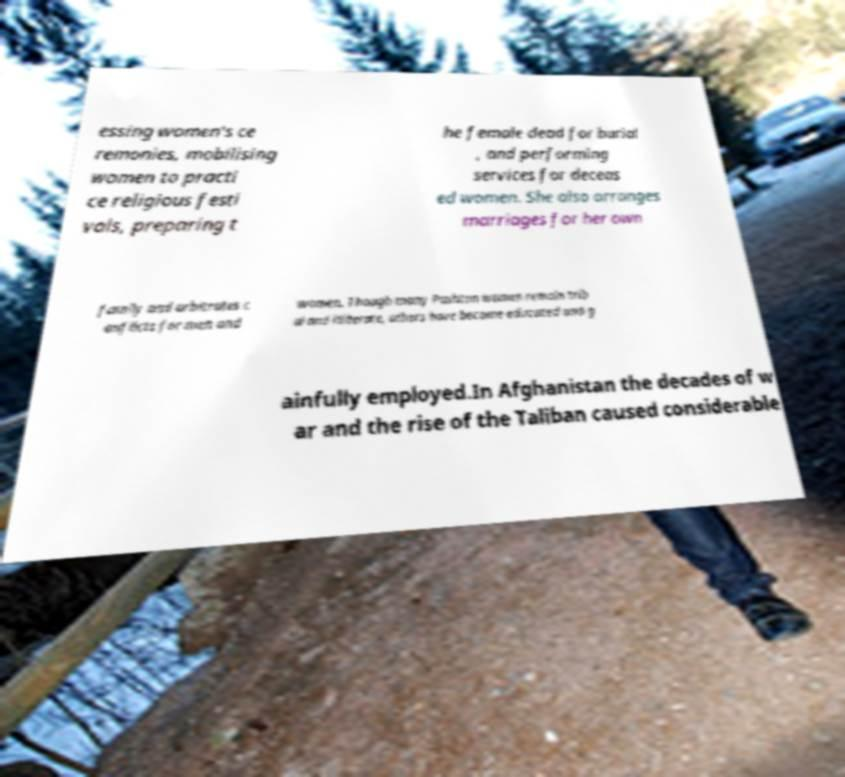Please identify and transcribe the text found in this image. essing women's ce remonies, mobilising women to practi ce religious festi vals, preparing t he female dead for burial , and performing services for deceas ed women. She also arranges marriages for her own family and arbitrates c onflicts for men and women. Though many Pashtun women remain trib al and illiterate, others have become educated and g ainfully employed.In Afghanistan the decades of w ar and the rise of the Taliban caused considerable 